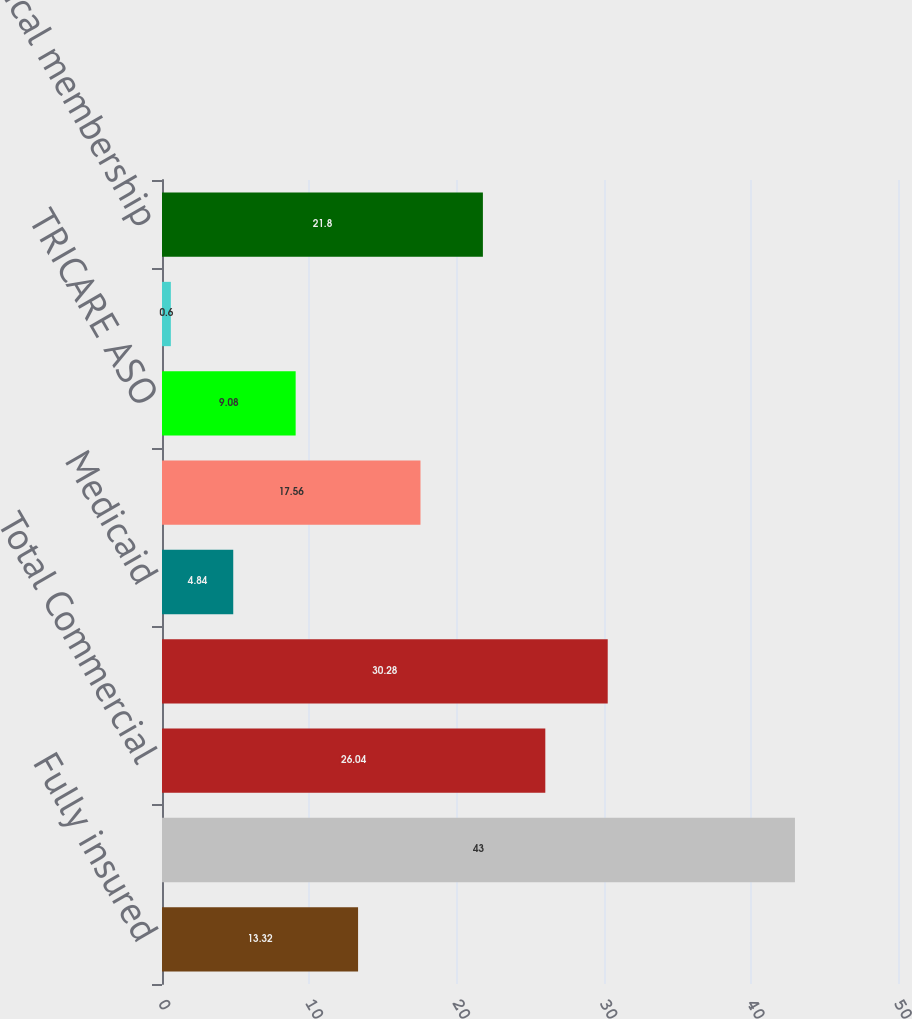Convert chart to OTSL. <chart><loc_0><loc_0><loc_500><loc_500><bar_chart><fcel>Fully insured<fcel>ASO<fcel>Total Commercial<fcel>Medicare Advantage<fcel>Medicaid<fcel>TRICARE<fcel>TRICARE ASO<fcel>Total Government<fcel>Total medical membership<nl><fcel>13.32<fcel>43<fcel>26.04<fcel>30.28<fcel>4.84<fcel>17.56<fcel>9.08<fcel>0.6<fcel>21.8<nl></chart> 